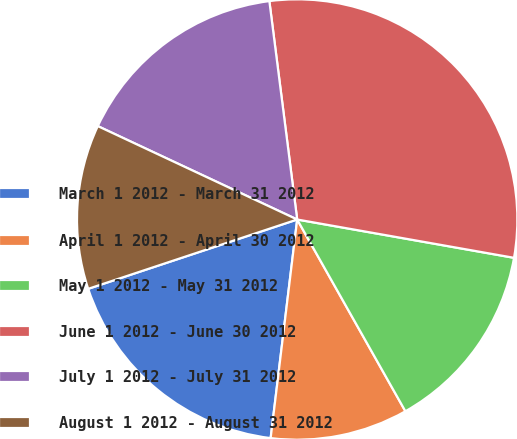Convert chart to OTSL. <chart><loc_0><loc_0><loc_500><loc_500><pie_chart><fcel>March 1 2012 - March 31 2012<fcel>April 1 2012 - April 30 2012<fcel>May 1 2012 - May 31 2012<fcel>June 1 2012 - June 30 2012<fcel>July 1 2012 - July 31 2012<fcel>August 1 2012 - August 31 2012<nl><fcel>17.98%<fcel>10.1%<fcel>14.04%<fcel>29.8%<fcel>16.01%<fcel>12.07%<nl></chart> 